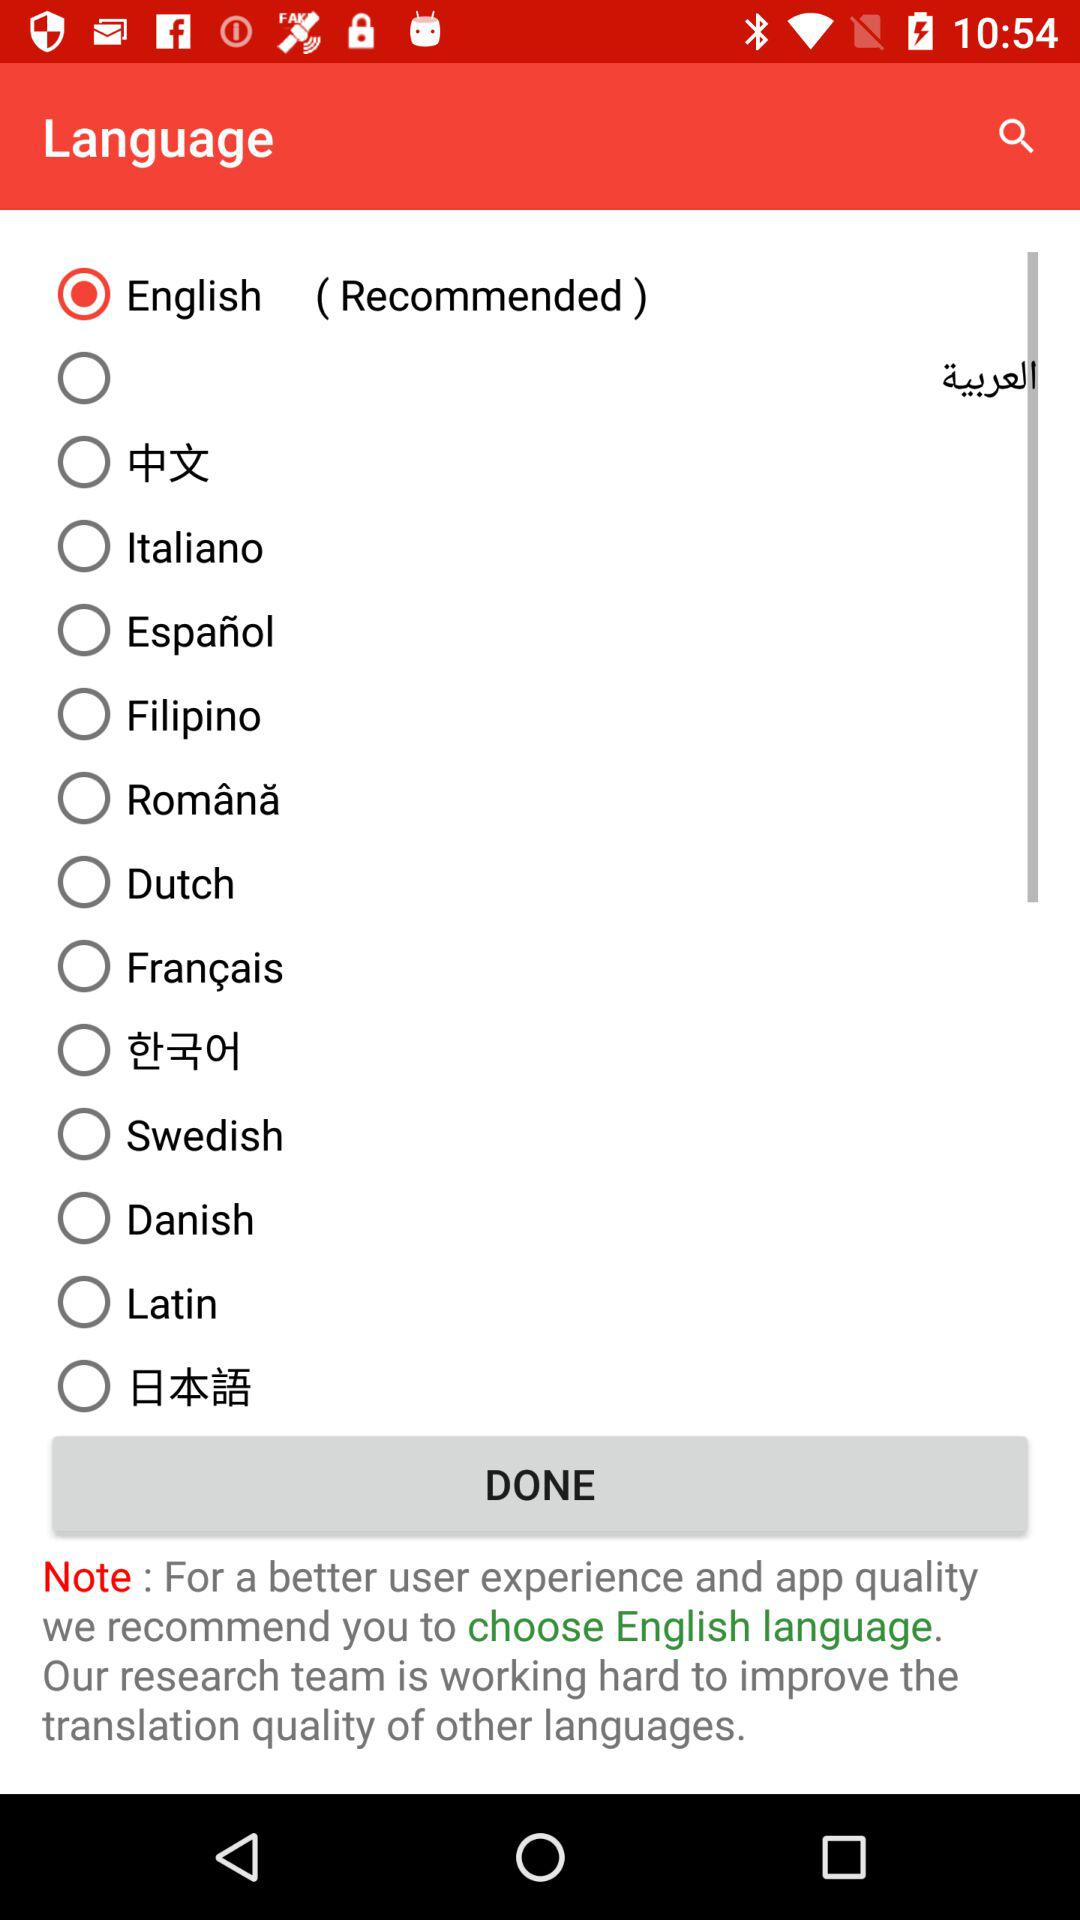Which language is selected? The selected language is English. 